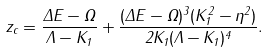Convert formula to latex. <formula><loc_0><loc_0><loc_500><loc_500>z _ { c } = \frac { \Delta E - \Omega } { \Lambda - K _ { 1 } } + \frac { ( \Delta E - \Omega ) ^ { 3 } ( K _ { 1 } ^ { 2 } - \eta ^ { 2 } ) } { 2 K _ { 1 } ( \Lambda - K _ { 1 } ) ^ { 4 } } .</formula> 